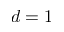<formula> <loc_0><loc_0><loc_500><loc_500>d = 1</formula> 